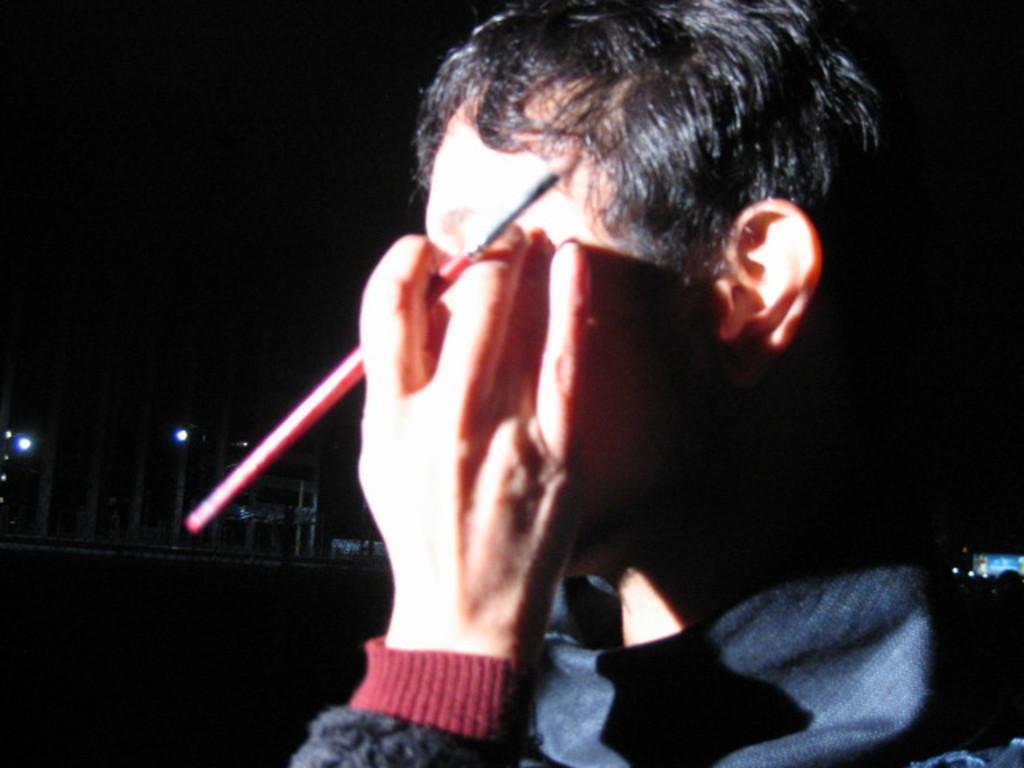How would you summarize this image in a sentence or two? In this picture we can see a person is holding a brush. Behind the person, those are looking like buildings and lights. 